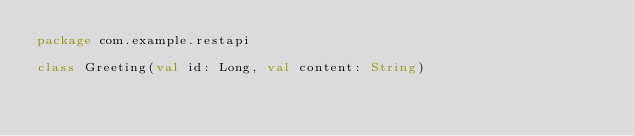Convert code to text. <code><loc_0><loc_0><loc_500><loc_500><_Kotlin_>package com.example.restapi

class Greeting(val id: Long, val content: String)
</code> 